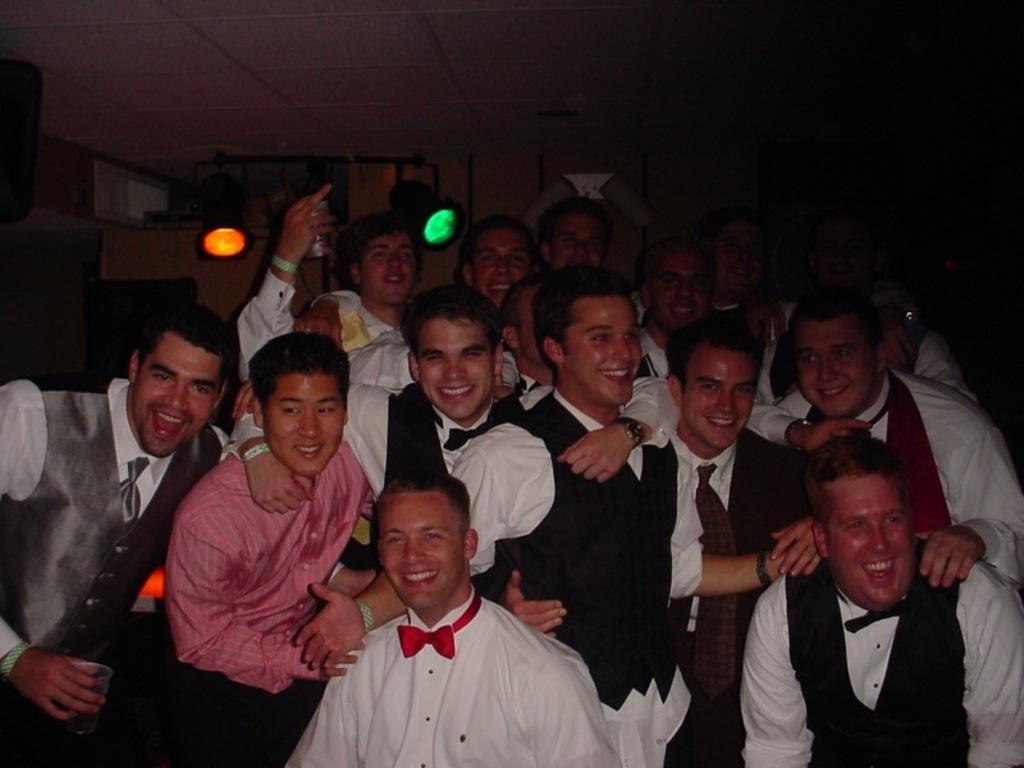In one or two sentences, can you explain what this image depicts? Here in this picture we can see a group of people standing over a place and all of them are smiling and some people are holding glasses in their hand s and behind them we can see colorful lights present over there. 